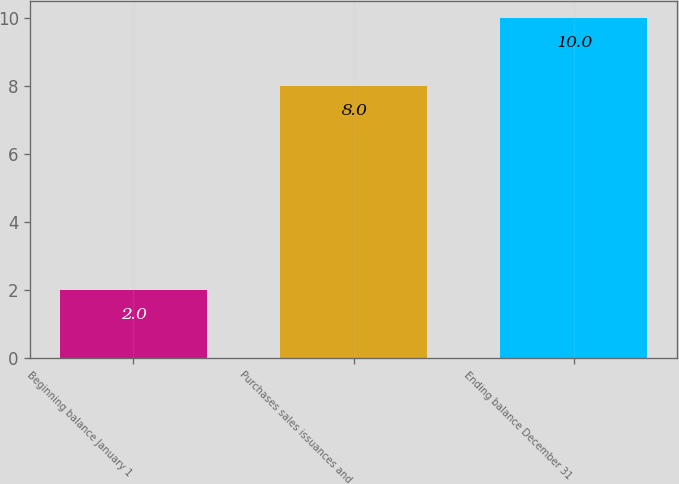Convert chart to OTSL. <chart><loc_0><loc_0><loc_500><loc_500><bar_chart><fcel>Beginning balance January 1<fcel>Purchases sales issuances and<fcel>Ending balance December 31<nl><fcel>2<fcel>8<fcel>10<nl></chart> 